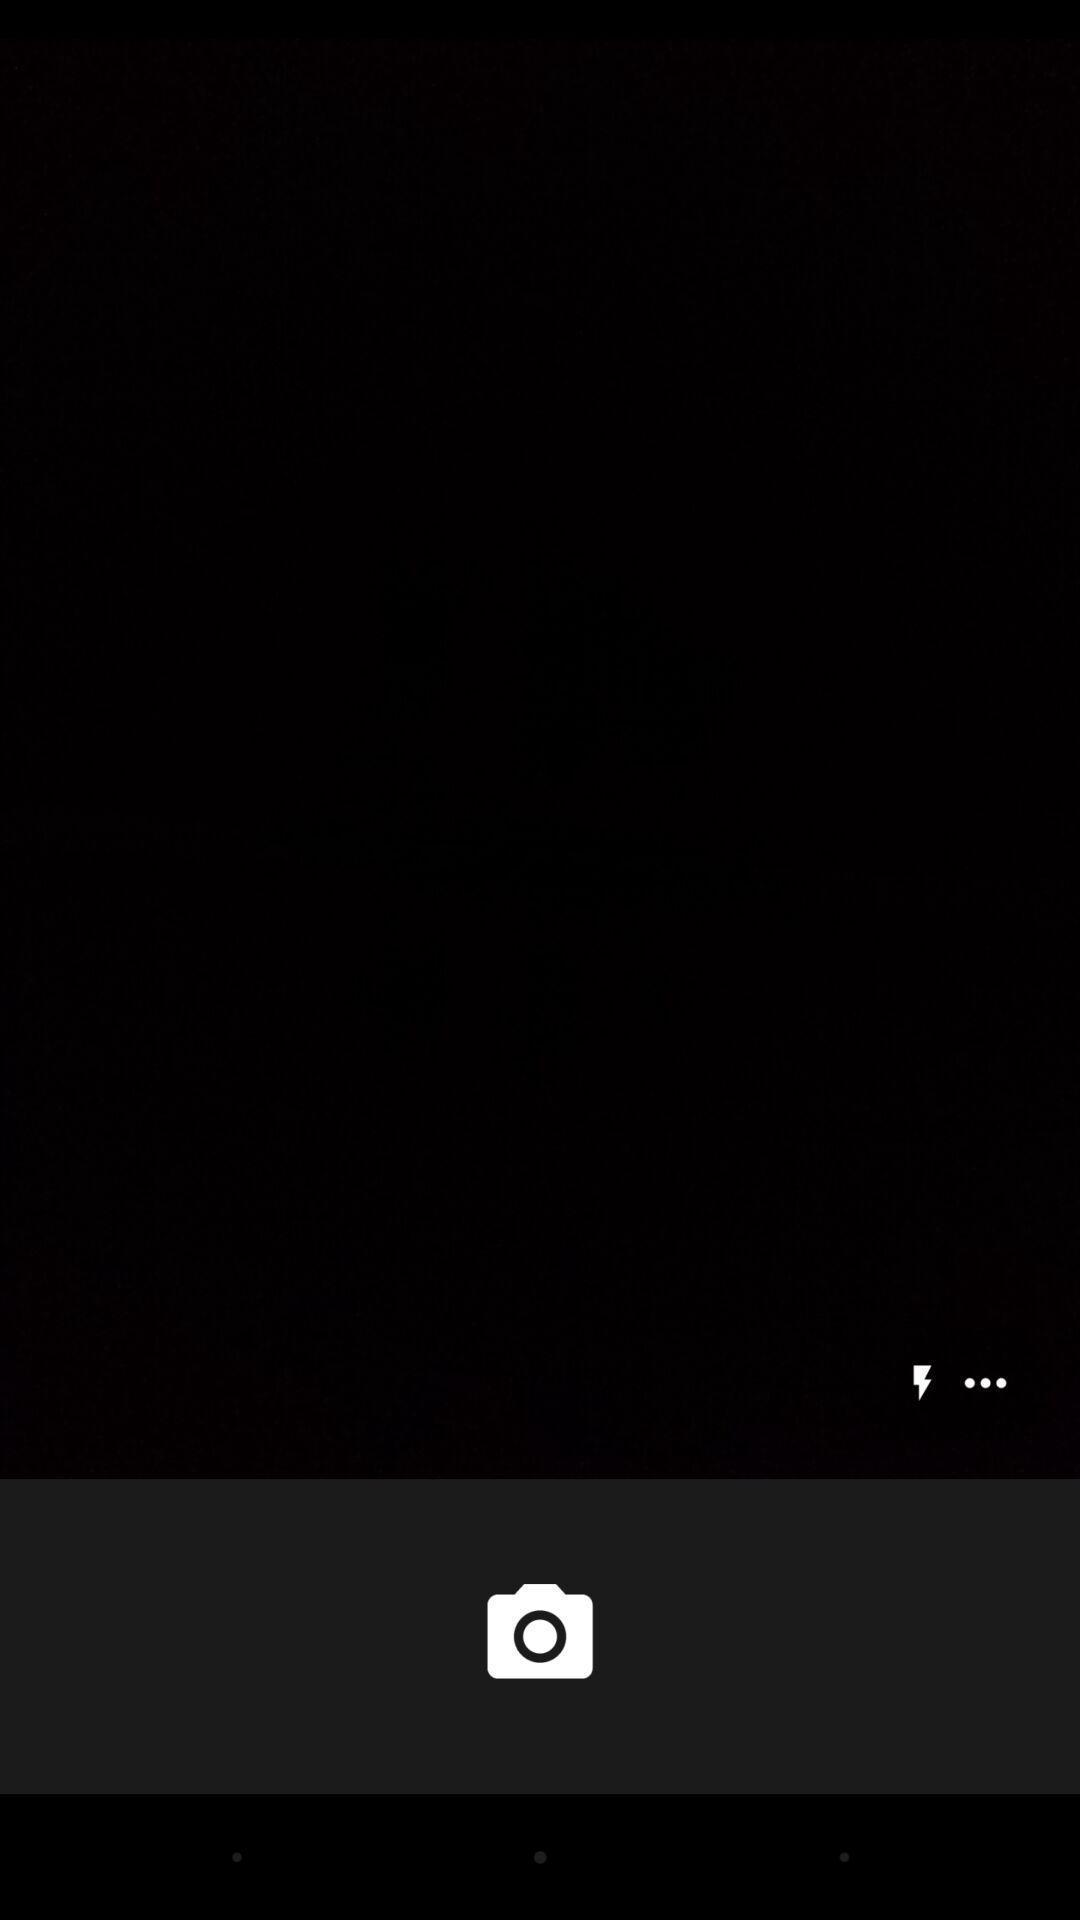Explain what's happening in this screen capture. Screen displaying a camera page. 